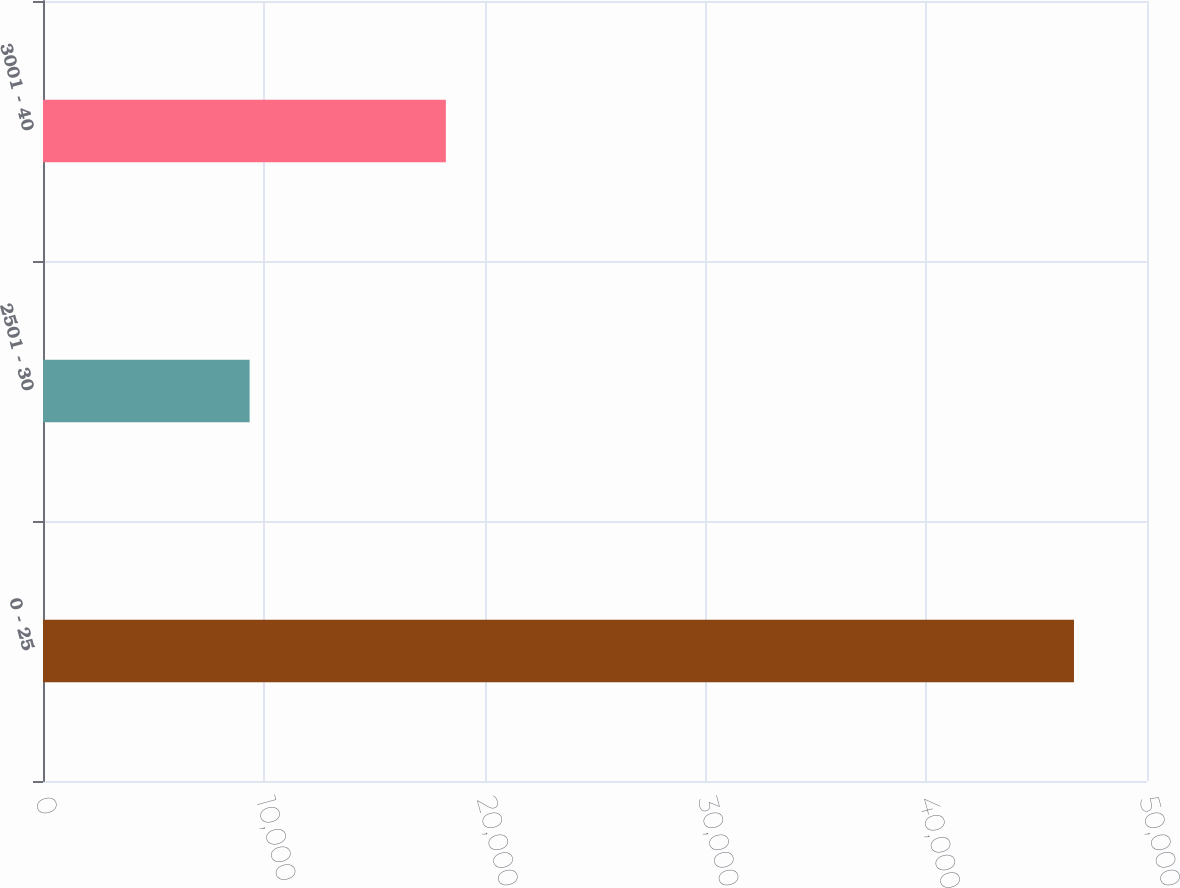Convert chart. <chart><loc_0><loc_0><loc_500><loc_500><bar_chart><fcel>0 - 25<fcel>2501 - 30<fcel>3001 - 40<nl><fcel>46693<fcel>9358<fcel>18245<nl></chart> 